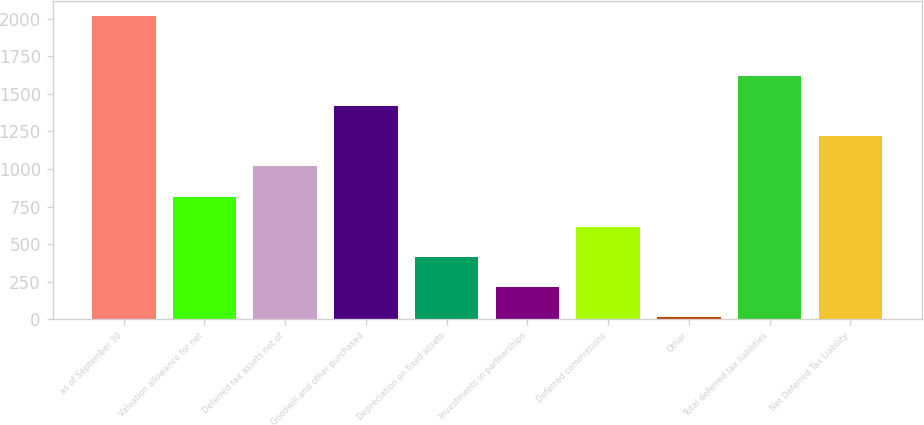Convert chart. <chart><loc_0><loc_0><loc_500><loc_500><bar_chart><fcel>as of September 30<fcel>Valuation allowance for net<fcel>Deferred tax assets net of<fcel>Goodwill and other purchased<fcel>Depreciation on fixed assets<fcel>Investments in partnerships<fcel>Deferred commissions<fcel>Other<fcel>Total deferred tax liabilities<fcel>Net Deferred Tax Liability<nl><fcel>2016<fcel>816.3<fcel>1016.25<fcel>1416.15<fcel>416.4<fcel>216.45<fcel>616.35<fcel>16.5<fcel>1616.1<fcel>1216.2<nl></chart> 